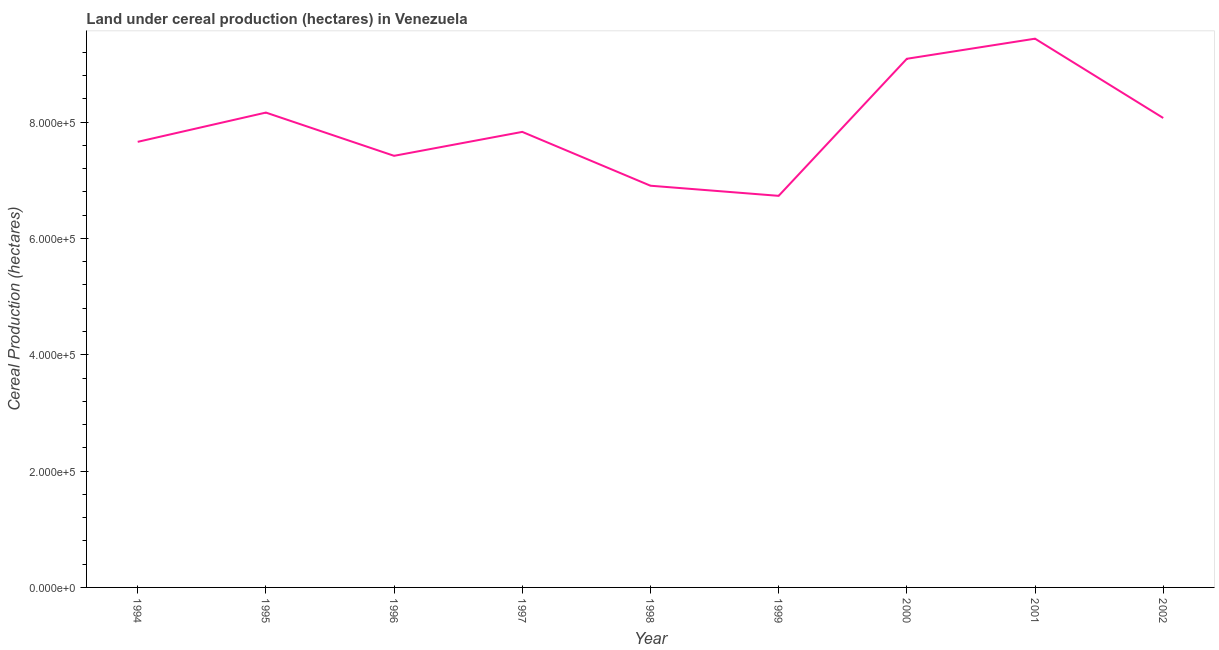What is the land under cereal production in 2001?
Make the answer very short. 9.44e+05. Across all years, what is the maximum land under cereal production?
Give a very brief answer. 9.44e+05. Across all years, what is the minimum land under cereal production?
Keep it short and to the point. 6.73e+05. In which year was the land under cereal production minimum?
Make the answer very short. 1999. What is the sum of the land under cereal production?
Give a very brief answer. 7.13e+06. What is the difference between the land under cereal production in 1995 and 1999?
Provide a succinct answer. 1.43e+05. What is the average land under cereal production per year?
Your answer should be compact. 7.92e+05. What is the median land under cereal production?
Give a very brief answer. 7.83e+05. What is the ratio of the land under cereal production in 1999 to that in 2002?
Keep it short and to the point. 0.83. What is the difference between the highest and the second highest land under cereal production?
Offer a very short reply. 3.46e+04. What is the difference between the highest and the lowest land under cereal production?
Give a very brief answer. 2.70e+05. Are the values on the major ticks of Y-axis written in scientific E-notation?
Give a very brief answer. Yes. Does the graph contain any zero values?
Your answer should be compact. No. Does the graph contain grids?
Your answer should be very brief. No. What is the title of the graph?
Make the answer very short. Land under cereal production (hectares) in Venezuela. What is the label or title of the Y-axis?
Offer a very short reply. Cereal Production (hectares). What is the Cereal Production (hectares) in 1994?
Ensure brevity in your answer.  7.66e+05. What is the Cereal Production (hectares) of 1995?
Provide a succinct answer. 8.16e+05. What is the Cereal Production (hectares) in 1996?
Provide a short and direct response. 7.42e+05. What is the Cereal Production (hectares) of 1997?
Keep it short and to the point. 7.83e+05. What is the Cereal Production (hectares) in 1998?
Offer a very short reply. 6.91e+05. What is the Cereal Production (hectares) of 1999?
Provide a succinct answer. 6.73e+05. What is the Cereal Production (hectares) of 2000?
Your answer should be compact. 9.09e+05. What is the Cereal Production (hectares) of 2001?
Your answer should be compact. 9.44e+05. What is the Cereal Production (hectares) of 2002?
Your answer should be compact. 8.07e+05. What is the difference between the Cereal Production (hectares) in 1994 and 1995?
Give a very brief answer. -5.03e+04. What is the difference between the Cereal Production (hectares) in 1994 and 1996?
Give a very brief answer. 2.40e+04. What is the difference between the Cereal Production (hectares) in 1994 and 1997?
Provide a short and direct response. -1.71e+04. What is the difference between the Cereal Production (hectares) in 1994 and 1998?
Offer a very short reply. 7.54e+04. What is the difference between the Cereal Production (hectares) in 1994 and 1999?
Your answer should be very brief. 9.29e+04. What is the difference between the Cereal Production (hectares) in 1994 and 2000?
Your answer should be compact. -1.43e+05. What is the difference between the Cereal Production (hectares) in 1994 and 2001?
Make the answer very short. -1.77e+05. What is the difference between the Cereal Production (hectares) in 1994 and 2002?
Your answer should be very brief. -4.10e+04. What is the difference between the Cereal Production (hectares) in 1995 and 1996?
Your answer should be very brief. 7.44e+04. What is the difference between the Cereal Production (hectares) in 1995 and 1997?
Offer a very short reply. 3.32e+04. What is the difference between the Cereal Production (hectares) in 1995 and 1998?
Provide a short and direct response. 1.26e+05. What is the difference between the Cereal Production (hectares) in 1995 and 1999?
Your answer should be very brief. 1.43e+05. What is the difference between the Cereal Production (hectares) in 1995 and 2000?
Provide a short and direct response. -9.25e+04. What is the difference between the Cereal Production (hectares) in 1995 and 2001?
Give a very brief answer. -1.27e+05. What is the difference between the Cereal Production (hectares) in 1995 and 2002?
Your response must be concise. 9318. What is the difference between the Cereal Production (hectares) in 1996 and 1997?
Your response must be concise. -4.11e+04. What is the difference between the Cereal Production (hectares) in 1996 and 1998?
Keep it short and to the point. 5.14e+04. What is the difference between the Cereal Production (hectares) in 1996 and 1999?
Your response must be concise. 6.88e+04. What is the difference between the Cereal Production (hectares) in 1996 and 2000?
Make the answer very short. -1.67e+05. What is the difference between the Cereal Production (hectares) in 1996 and 2001?
Your answer should be very brief. -2.01e+05. What is the difference between the Cereal Production (hectares) in 1996 and 2002?
Give a very brief answer. -6.50e+04. What is the difference between the Cereal Production (hectares) in 1997 and 1998?
Provide a succinct answer. 9.25e+04. What is the difference between the Cereal Production (hectares) in 1997 and 1999?
Provide a short and direct response. 1.10e+05. What is the difference between the Cereal Production (hectares) in 1997 and 2000?
Your response must be concise. -1.26e+05. What is the difference between the Cereal Production (hectares) in 1997 and 2001?
Make the answer very short. -1.60e+05. What is the difference between the Cereal Production (hectares) in 1997 and 2002?
Your response must be concise. -2.39e+04. What is the difference between the Cereal Production (hectares) in 1998 and 1999?
Offer a very short reply. 1.74e+04. What is the difference between the Cereal Production (hectares) in 1998 and 2000?
Ensure brevity in your answer.  -2.18e+05. What is the difference between the Cereal Production (hectares) in 1998 and 2001?
Offer a very short reply. -2.53e+05. What is the difference between the Cereal Production (hectares) in 1998 and 2002?
Ensure brevity in your answer.  -1.16e+05. What is the difference between the Cereal Production (hectares) in 1999 and 2000?
Ensure brevity in your answer.  -2.36e+05. What is the difference between the Cereal Production (hectares) in 1999 and 2001?
Provide a succinct answer. -2.70e+05. What is the difference between the Cereal Production (hectares) in 1999 and 2002?
Your answer should be compact. -1.34e+05. What is the difference between the Cereal Production (hectares) in 2000 and 2001?
Make the answer very short. -3.46e+04. What is the difference between the Cereal Production (hectares) in 2000 and 2002?
Give a very brief answer. 1.02e+05. What is the difference between the Cereal Production (hectares) in 2001 and 2002?
Keep it short and to the point. 1.36e+05. What is the ratio of the Cereal Production (hectares) in 1994 to that in 1995?
Offer a terse response. 0.94. What is the ratio of the Cereal Production (hectares) in 1994 to that in 1996?
Offer a very short reply. 1.03. What is the ratio of the Cereal Production (hectares) in 1994 to that in 1997?
Offer a very short reply. 0.98. What is the ratio of the Cereal Production (hectares) in 1994 to that in 1998?
Your response must be concise. 1.11. What is the ratio of the Cereal Production (hectares) in 1994 to that in 1999?
Your response must be concise. 1.14. What is the ratio of the Cereal Production (hectares) in 1994 to that in 2000?
Make the answer very short. 0.84. What is the ratio of the Cereal Production (hectares) in 1994 to that in 2001?
Give a very brief answer. 0.81. What is the ratio of the Cereal Production (hectares) in 1994 to that in 2002?
Ensure brevity in your answer.  0.95. What is the ratio of the Cereal Production (hectares) in 1995 to that in 1997?
Give a very brief answer. 1.04. What is the ratio of the Cereal Production (hectares) in 1995 to that in 1998?
Offer a terse response. 1.18. What is the ratio of the Cereal Production (hectares) in 1995 to that in 1999?
Ensure brevity in your answer.  1.21. What is the ratio of the Cereal Production (hectares) in 1995 to that in 2000?
Your response must be concise. 0.9. What is the ratio of the Cereal Production (hectares) in 1995 to that in 2001?
Your response must be concise. 0.86. What is the ratio of the Cereal Production (hectares) in 1995 to that in 2002?
Offer a very short reply. 1.01. What is the ratio of the Cereal Production (hectares) in 1996 to that in 1997?
Make the answer very short. 0.95. What is the ratio of the Cereal Production (hectares) in 1996 to that in 1998?
Your answer should be very brief. 1.07. What is the ratio of the Cereal Production (hectares) in 1996 to that in 1999?
Offer a very short reply. 1.1. What is the ratio of the Cereal Production (hectares) in 1996 to that in 2000?
Your response must be concise. 0.82. What is the ratio of the Cereal Production (hectares) in 1996 to that in 2001?
Your answer should be very brief. 0.79. What is the ratio of the Cereal Production (hectares) in 1996 to that in 2002?
Your answer should be very brief. 0.92. What is the ratio of the Cereal Production (hectares) in 1997 to that in 1998?
Your response must be concise. 1.13. What is the ratio of the Cereal Production (hectares) in 1997 to that in 1999?
Provide a short and direct response. 1.16. What is the ratio of the Cereal Production (hectares) in 1997 to that in 2000?
Provide a succinct answer. 0.86. What is the ratio of the Cereal Production (hectares) in 1997 to that in 2001?
Offer a terse response. 0.83. What is the ratio of the Cereal Production (hectares) in 1997 to that in 2002?
Keep it short and to the point. 0.97. What is the ratio of the Cereal Production (hectares) in 1998 to that in 1999?
Provide a succinct answer. 1.03. What is the ratio of the Cereal Production (hectares) in 1998 to that in 2000?
Provide a succinct answer. 0.76. What is the ratio of the Cereal Production (hectares) in 1998 to that in 2001?
Offer a very short reply. 0.73. What is the ratio of the Cereal Production (hectares) in 1998 to that in 2002?
Ensure brevity in your answer.  0.86. What is the ratio of the Cereal Production (hectares) in 1999 to that in 2000?
Your answer should be compact. 0.74. What is the ratio of the Cereal Production (hectares) in 1999 to that in 2001?
Ensure brevity in your answer.  0.71. What is the ratio of the Cereal Production (hectares) in 1999 to that in 2002?
Make the answer very short. 0.83. What is the ratio of the Cereal Production (hectares) in 2000 to that in 2002?
Ensure brevity in your answer.  1.13. What is the ratio of the Cereal Production (hectares) in 2001 to that in 2002?
Make the answer very short. 1.17. 